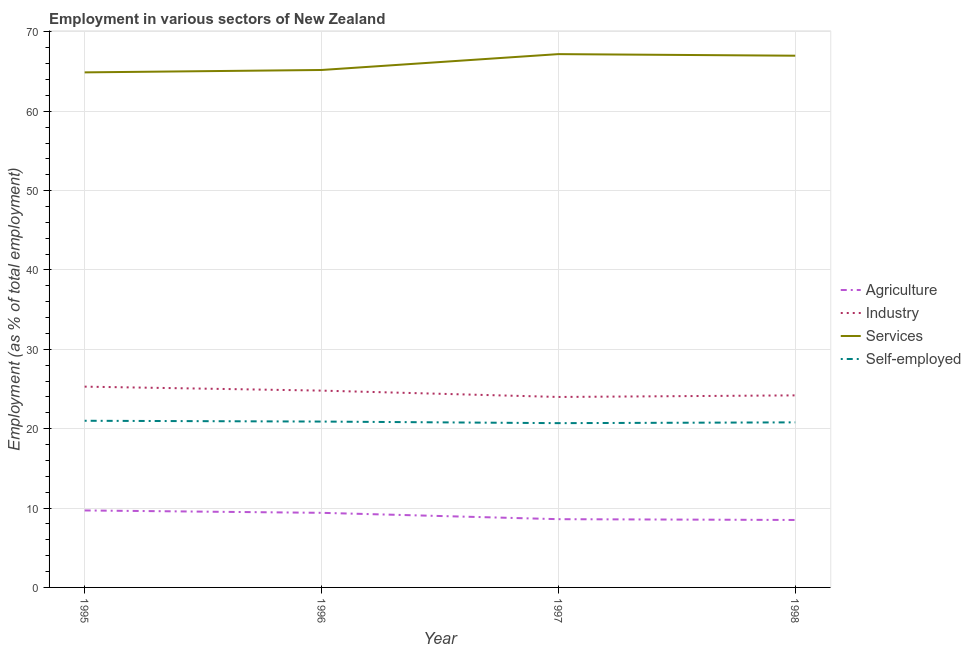Does the line corresponding to percentage of workers in agriculture intersect with the line corresponding to percentage of self employed workers?
Ensure brevity in your answer.  No. Is the number of lines equal to the number of legend labels?
Keep it short and to the point. Yes. What is the percentage of workers in agriculture in 1997?
Your response must be concise. 8.6. Across all years, what is the maximum percentage of workers in services?
Give a very brief answer. 67.2. Across all years, what is the minimum percentage of workers in agriculture?
Give a very brief answer. 8.5. What is the total percentage of workers in agriculture in the graph?
Offer a terse response. 36.2. What is the difference between the percentage of workers in services in 1996 and that in 1998?
Offer a terse response. -1.8. What is the difference between the percentage of self employed workers in 1998 and the percentage of workers in agriculture in 1996?
Your response must be concise. 11.4. What is the average percentage of workers in services per year?
Your answer should be compact. 66.07. In the year 1996, what is the difference between the percentage of workers in agriculture and percentage of workers in industry?
Make the answer very short. -15.4. What is the ratio of the percentage of self employed workers in 1996 to that in 1997?
Your response must be concise. 1.01. Is the percentage of workers in services in 1995 less than that in 1996?
Make the answer very short. Yes. Is the difference between the percentage of workers in services in 1997 and 1998 greater than the difference between the percentage of self employed workers in 1997 and 1998?
Provide a succinct answer. Yes. What is the difference between the highest and the second highest percentage of workers in industry?
Keep it short and to the point. 0.5. What is the difference between the highest and the lowest percentage of workers in services?
Your answer should be compact. 2.3. In how many years, is the percentage of workers in services greater than the average percentage of workers in services taken over all years?
Keep it short and to the point. 2. Is the sum of the percentage of workers in agriculture in 1996 and 1998 greater than the maximum percentage of self employed workers across all years?
Keep it short and to the point. No. Is it the case that in every year, the sum of the percentage of workers in agriculture and percentage of workers in industry is greater than the percentage of workers in services?
Provide a short and direct response. No. Does the percentage of self employed workers monotonically increase over the years?
Your answer should be very brief. No. Is the percentage of workers in industry strictly greater than the percentage of workers in services over the years?
Your answer should be compact. No. Is the percentage of self employed workers strictly less than the percentage of workers in services over the years?
Offer a terse response. Yes. How many lines are there?
Your response must be concise. 4. How many years are there in the graph?
Ensure brevity in your answer.  4. Does the graph contain any zero values?
Keep it short and to the point. No. How many legend labels are there?
Your answer should be compact. 4. How are the legend labels stacked?
Your answer should be compact. Vertical. What is the title of the graph?
Provide a short and direct response. Employment in various sectors of New Zealand. Does "Rule based governance" appear as one of the legend labels in the graph?
Provide a succinct answer. No. What is the label or title of the X-axis?
Your answer should be compact. Year. What is the label or title of the Y-axis?
Give a very brief answer. Employment (as % of total employment). What is the Employment (as % of total employment) of Agriculture in 1995?
Your answer should be compact. 9.7. What is the Employment (as % of total employment) of Industry in 1995?
Provide a short and direct response. 25.3. What is the Employment (as % of total employment) of Services in 1995?
Offer a terse response. 64.9. What is the Employment (as % of total employment) in Agriculture in 1996?
Keep it short and to the point. 9.4. What is the Employment (as % of total employment) in Industry in 1996?
Your response must be concise. 24.8. What is the Employment (as % of total employment) in Services in 1996?
Keep it short and to the point. 65.2. What is the Employment (as % of total employment) of Self-employed in 1996?
Offer a terse response. 20.9. What is the Employment (as % of total employment) in Agriculture in 1997?
Make the answer very short. 8.6. What is the Employment (as % of total employment) of Industry in 1997?
Offer a very short reply. 24. What is the Employment (as % of total employment) of Services in 1997?
Provide a short and direct response. 67.2. What is the Employment (as % of total employment) of Self-employed in 1997?
Provide a short and direct response. 20.7. What is the Employment (as % of total employment) in Industry in 1998?
Provide a succinct answer. 24.2. What is the Employment (as % of total employment) in Self-employed in 1998?
Your answer should be compact. 20.8. Across all years, what is the maximum Employment (as % of total employment) of Agriculture?
Make the answer very short. 9.7. Across all years, what is the maximum Employment (as % of total employment) in Industry?
Make the answer very short. 25.3. Across all years, what is the maximum Employment (as % of total employment) in Services?
Give a very brief answer. 67.2. Across all years, what is the minimum Employment (as % of total employment) of Services?
Your response must be concise. 64.9. Across all years, what is the minimum Employment (as % of total employment) of Self-employed?
Offer a terse response. 20.7. What is the total Employment (as % of total employment) in Agriculture in the graph?
Provide a succinct answer. 36.2. What is the total Employment (as % of total employment) in Industry in the graph?
Provide a succinct answer. 98.3. What is the total Employment (as % of total employment) in Services in the graph?
Provide a succinct answer. 264.3. What is the total Employment (as % of total employment) in Self-employed in the graph?
Your answer should be compact. 83.4. What is the difference between the Employment (as % of total employment) in Services in 1995 and that in 1996?
Your response must be concise. -0.3. What is the difference between the Employment (as % of total employment) of Agriculture in 1995 and that in 1997?
Keep it short and to the point. 1.1. What is the difference between the Employment (as % of total employment) in Self-employed in 1995 and that in 1997?
Your answer should be very brief. 0.3. What is the difference between the Employment (as % of total employment) in Industry in 1995 and that in 1998?
Your answer should be very brief. 1.1. What is the difference between the Employment (as % of total employment) of Services in 1995 and that in 1998?
Provide a short and direct response. -2.1. What is the difference between the Employment (as % of total employment) of Agriculture in 1996 and that in 1997?
Provide a succinct answer. 0.8. What is the difference between the Employment (as % of total employment) in Industry in 1996 and that in 1997?
Offer a very short reply. 0.8. What is the difference between the Employment (as % of total employment) of Self-employed in 1996 and that in 1997?
Provide a succinct answer. 0.2. What is the difference between the Employment (as % of total employment) in Services in 1996 and that in 1998?
Give a very brief answer. -1.8. What is the difference between the Employment (as % of total employment) in Industry in 1997 and that in 1998?
Your answer should be compact. -0.2. What is the difference between the Employment (as % of total employment) of Services in 1997 and that in 1998?
Offer a very short reply. 0.2. What is the difference between the Employment (as % of total employment) of Agriculture in 1995 and the Employment (as % of total employment) of Industry in 1996?
Keep it short and to the point. -15.1. What is the difference between the Employment (as % of total employment) of Agriculture in 1995 and the Employment (as % of total employment) of Services in 1996?
Your answer should be very brief. -55.5. What is the difference between the Employment (as % of total employment) of Industry in 1995 and the Employment (as % of total employment) of Services in 1996?
Your response must be concise. -39.9. What is the difference between the Employment (as % of total employment) of Agriculture in 1995 and the Employment (as % of total employment) of Industry in 1997?
Your answer should be very brief. -14.3. What is the difference between the Employment (as % of total employment) of Agriculture in 1995 and the Employment (as % of total employment) of Services in 1997?
Your response must be concise. -57.5. What is the difference between the Employment (as % of total employment) in Industry in 1995 and the Employment (as % of total employment) in Services in 1997?
Provide a short and direct response. -41.9. What is the difference between the Employment (as % of total employment) of Industry in 1995 and the Employment (as % of total employment) of Self-employed in 1997?
Offer a terse response. 4.6. What is the difference between the Employment (as % of total employment) in Services in 1995 and the Employment (as % of total employment) in Self-employed in 1997?
Make the answer very short. 44.2. What is the difference between the Employment (as % of total employment) in Agriculture in 1995 and the Employment (as % of total employment) in Services in 1998?
Your answer should be compact. -57.3. What is the difference between the Employment (as % of total employment) of Industry in 1995 and the Employment (as % of total employment) of Services in 1998?
Offer a terse response. -41.7. What is the difference between the Employment (as % of total employment) in Industry in 1995 and the Employment (as % of total employment) in Self-employed in 1998?
Give a very brief answer. 4.5. What is the difference between the Employment (as % of total employment) of Services in 1995 and the Employment (as % of total employment) of Self-employed in 1998?
Your answer should be compact. 44.1. What is the difference between the Employment (as % of total employment) in Agriculture in 1996 and the Employment (as % of total employment) in Industry in 1997?
Offer a very short reply. -14.6. What is the difference between the Employment (as % of total employment) in Agriculture in 1996 and the Employment (as % of total employment) in Services in 1997?
Provide a short and direct response. -57.8. What is the difference between the Employment (as % of total employment) of Industry in 1996 and the Employment (as % of total employment) of Services in 1997?
Ensure brevity in your answer.  -42.4. What is the difference between the Employment (as % of total employment) in Industry in 1996 and the Employment (as % of total employment) in Self-employed in 1997?
Make the answer very short. 4.1. What is the difference between the Employment (as % of total employment) of Services in 1996 and the Employment (as % of total employment) of Self-employed in 1997?
Make the answer very short. 44.5. What is the difference between the Employment (as % of total employment) in Agriculture in 1996 and the Employment (as % of total employment) in Industry in 1998?
Your answer should be very brief. -14.8. What is the difference between the Employment (as % of total employment) of Agriculture in 1996 and the Employment (as % of total employment) of Services in 1998?
Your answer should be compact. -57.6. What is the difference between the Employment (as % of total employment) in Agriculture in 1996 and the Employment (as % of total employment) in Self-employed in 1998?
Ensure brevity in your answer.  -11.4. What is the difference between the Employment (as % of total employment) in Industry in 1996 and the Employment (as % of total employment) in Services in 1998?
Provide a short and direct response. -42.2. What is the difference between the Employment (as % of total employment) in Services in 1996 and the Employment (as % of total employment) in Self-employed in 1998?
Give a very brief answer. 44.4. What is the difference between the Employment (as % of total employment) of Agriculture in 1997 and the Employment (as % of total employment) of Industry in 1998?
Provide a short and direct response. -15.6. What is the difference between the Employment (as % of total employment) in Agriculture in 1997 and the Employment (as % of total employment) in Services in 1998?
Give a very brief answer. -58.4. What is the difference between the Employment (as % of total employment) in Industry in 1997 and the Employment (as % of total employment) in Services in 1998?
Your response must be concise. -43. What is the difference between the Employment (as % of total employment) in Services in 1997 and the Employment (as % of total employment) in Self-employed in 1998?
Offer a very short reply. 46.4. What is the average Employment (as % of total employment) of Agriculture per year?
Keep it short and to the point. 9.05. What is the average Employment (as % of total employment) of Industry per year?
Make the answer very short. 24.57. What is the average Employment (as % of total employment) of Services per year?
Offer a terse response. 66.08. What is the average Employment (as % of total employment) in Self-employed per year?
Your answer should be compact. 20.85. In the year 1995, what is the difference between the Employment (as % of total employment) in Agriculture and Employment (as % of total employment) in Industry?
Make the answer very short. -15.6. In the year 1995, what is the difference between the Employment (as % of total employment) of Agriculture and Employment (as % of total employment) of Services?
Your answer should be compact. -55.2. In the year 1995, what is the difference between the Employment (as % of total employment) of Industry and Employment (as % of total employment) of Services?
Give a very brief answer. -39.6. In the year 1995, what is the difference between the Employment (as % of total employment) of Industry and Employment (as % of total employment) of Self-employed?
Your answer should be very brief. 4.3. In the year 1995, what is the difference between the Employment (as % of total employment) in Services and Employment (as % of total employment) in Self-employed?
Provide a short and direct response. 43.9. In the year 1996, what is the difference between the Employment (as % of total employment) of Agriculture and Employment (as % of total employment) of Industry?
Your response must be concise. -15.4. In the year 1996, what is the difference between the Employment (as % of total employment) of Agriculture and Employment (as % of total employment) of Services?
Provide a short and direct response. -55.8. In the year 1996, what is the difference between the Employment (as % of total employment) of Agriculture and Employment (as % of total employment) of Self-employed?
Your answer should be very brief. -11.5. In the year 1996, what is the difference between the Employment (as % of total employment) in Industry and Employment (as % of total employment) in Services?
Offer a very short reply. -40.4. In the year 1996, what is the difference between the Employment (as % of total employment) in Industry and Employment (as % of total employment) in Self-employed?
Make the answer very short. 3.9. In the year 1996, what is the difference between the Employment (as % of total employment) of Services and Employment (as % of total employment) of Self-employed?
Offer a terse response. 44.3. In the year 1997, what is the difference between the Employment (as % of total employment) in Agriculture and Employment (as % of total employment) in Industry?
Offer a very short reply. -15.4. In the year 1997, what is the difference between the Employment (as % of total employment) of Agriculture and Employment (as % of total employment) of Services?
Your answer should be compact. -58.6. In the year 1997, what is the difference between the Employment (as % of total employment) of Agriculture and Employment (as % of total employment) of Self-employed?
Your answer should be very brief. -12.1. In the year 1997, what is the difference between the Employment (as % of total employment) of Industry and Employment (as % of total employment) of Services?
Give a very brief answer. -43.2. In the year 1997, what is the difference between the Employment (as % of total employment) of Services and Employment (as % of total employment) of Self-employed?
Provide a short and direct response. 46.5. In the year 1998, what is the difference between the Employment (as % of total employment) in Agriculture and Employment (as % of total employment) in Industry?
Ensure brevity in your answer.  -15.7. In the year 1998, what is the difference between the Employment (as % of total employment) of Agriculture and Employment (as % of total employment) of Services?
Offer a terse response. -58.5. In the year 1998, what is the difference between the Employment (as % of total employment) in Agriculture and Employment (as % of total employment) in Self-employed?
Make the answer very short. -12.3. In the year 1998, what is the difference between the Employment (as % of total employment) of Industry and Employment (as % of total employment) of Services?
Provide a short and direct response. -42.8. In the year 1998, what is the difference between the Employment (as % of total employment) of Services and Employment (as % of total employment) of Self-employed?
Ensure brevity in your answer.  46.2. What is the ratio of the Employment (as % of total employment) of Agriculture in 1995 to that in 1996?
Your answer should be compact. 1.03. What is the ratio of the Employment (as % of total employment) in Industry in 1995 to that in 1996?
Offer a terse response. 1.02. What is the ratio of the Employment (as % of total employment) of Agriculture in 1995 to that in 1997?
Your answer should be compact. 1.13. What is the ratio of the Employment (as % of total employment) of Industry in 1995 to that in 1997?
Your response must be concise. 1.05. What is the ratio of the Employment (as % of total employment) of Services in 1995 to that in 1997?
Keep it short and to the point. 0.97. What is the ratio of the Employment (as % of total employment) in Self-employed in 1995 to that in 1997?
Provide a short and direct response. 1.01. What is the ratio of the Employment (as % of total employment) in Agriculture in 1995 to that in 1998?
Provide a short and direct response. 1.14. What is the ratio of the Employment (as % of total employment) of Industry in 1995 to that in 1998?
Provide a succinct answer. 1.05. What is the ratio of the Employment (as % of total employment) of Services in 1995 to that in 1998?
Provide a succinct answer. 0.97. What is the ratio of the Employment (as % of total employment) in Self-employed in 1995 to that in 1998?
Give a very brief answer. 1.01. What is the ratio of the Employment (as % of total employment) of Agriculture in 1996 to that in 1997?
Give a very brief answer. 1.09. What is the ratio of the Employment (as % of total employment) in Industry in 1996 to that in 1997?
Give a very brief answer. 1.03. What is the ratio of the Employment (as % of total employment) of Services in 1996 to that in 1997?
Give a very brief answer. 0.97. What is the ratio of the Employment (as % of total employment) of Self-employed in 1996 to that in 1997?
Provide a succinct answer. 1.01. What is the ratio of the Employment (as % of total employment) of Agriculture in 1996 to that in 1998?
Your answer should be compact. 1.11. What is the ratio of the Employment (as % of total employment) of Industry in 1996 to that in 1998?
Ensure brevity in your answer.  1.02. What is the ratio of the Employment (as % of total employment) in Services in 1996 to that in 1998?
Keep it short and to the point. 0.97. What is the ratio of the Employment (as % of total employment) of Agriculture in 1997 to that in 1998?
Provide a succinct answer. 1.01. What is the ratio of the Employment (as % of total employment) in Self-employed in 1997 to that in 1998?
Provide a succinct answer. 1. What is the difference between the highest and the second highest Employment (as % of total employment) in Services?
Offer a terse response. 0.2. What is the difference between the highest and the lowest Employment (as % of total employment) in Industry?
Keep it short and to the point. 1.3. What is the difference between the highest and the lowest Employment (as % of total employment) in Services?
Provide a short and direct response. 2.3. 